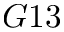Convert formula to latex. <formula><loc_0><loc_0><loc_500><loc_500>G 1 3</formula> 